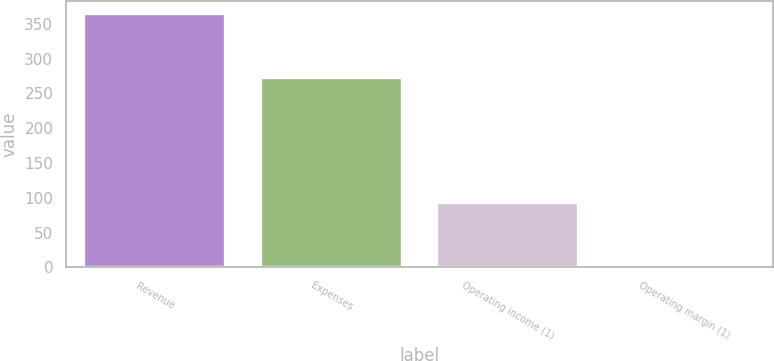Convert chart to OTSL. <chart><loc_0><loc_0><loc_500><loc_500><bar_chart><fcel>Revenue<fcel>Expenses<fcel>Operating income (1)<fcel>Operating margin (1)<nl><fcel>364<fcel>272<fcel>92<fcel>0.5<nl></chart> 